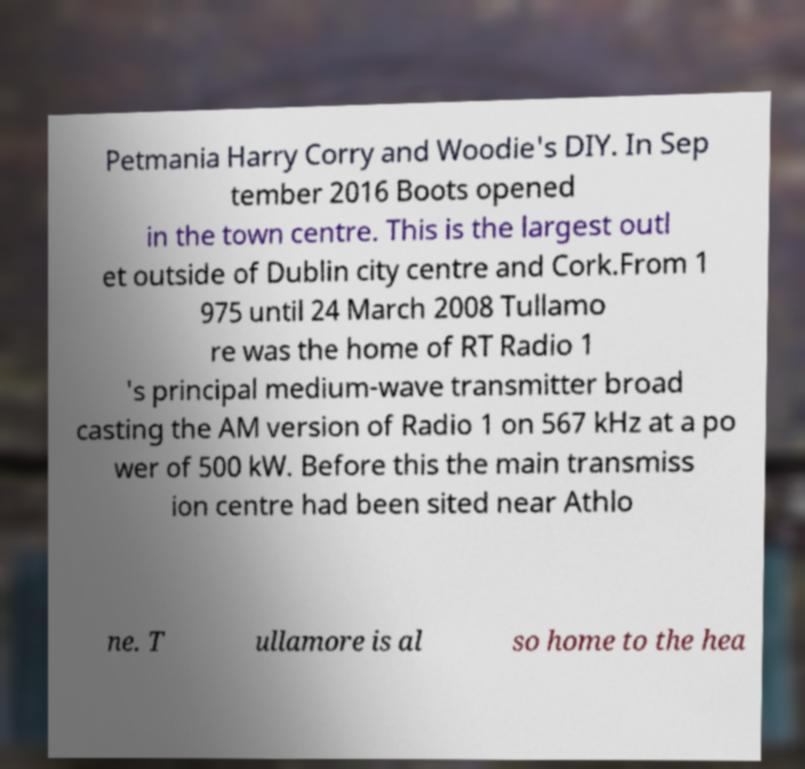Could you extract and type out the text from this image? Petmania Harry Corry and Woodie's DIY. In Sep tember 2016 Boots opened in the town centre. This is the largest outl et outside of Dublin city centre and Cork.From 1 975 until 24 March 2008 Tullamo re was the home of RT Radio 1 's principal medium-wave transmitter broad casting the AM version of Radio 1 on 567 kHz at a po wer of 500 kW. Before this the main transmiss ion centre had been sited near Athlo ne. T ullamore is al so home to the hea 